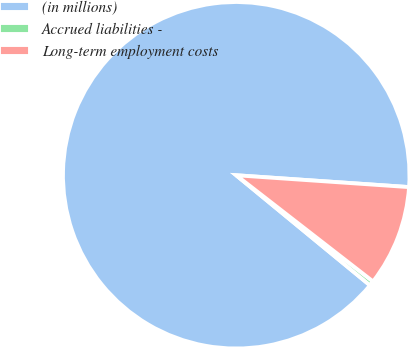Convert chart. <chart><loc_0><loc_0><loc_500><loc_500><pie_chart><fcel>(in millions)<fcel>Accrued liabilities -<fcel>Long-term employment costs<nl><fcel>90.14%<fcel>0.45%<fcel>9.42%<nl></chart> 